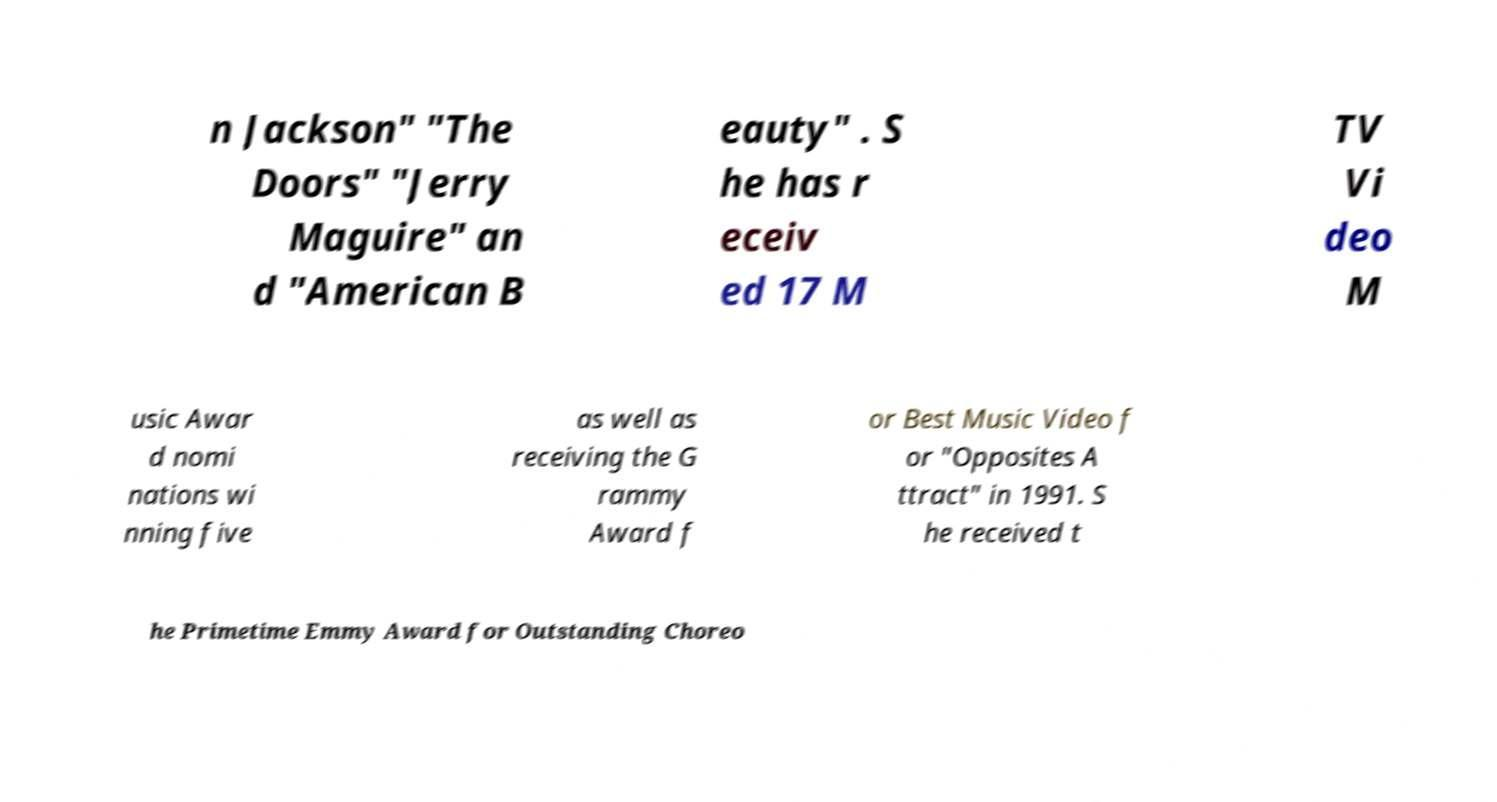For documentation purposes, I need the text within this image transcribed. Could you provide that? n Jackson" "The Doors" "Jerry Maguire" an d "American B eauty" . S he has r eceiv ed 17 M TV Vi deo M usic Awar d nomi nations wi nning five as well as receiving the G rammy Award f or Best Music Video f or "Opposites A ttract" in 1991. S he received t he Primetime Emmy Award for Outstanding Choreo 